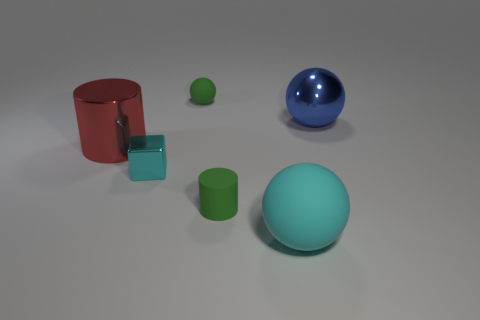Can you describe the shapes and their arrangements in the image? Certainly! The image features a collection of geometric shapes neatly spaced on a flat surface. At the forefront, there's a large teal-colored matte sphere. Slightly behind and to the left is a smaller aqua-colored cube, resting on its edge beside a vertically standing red matte cylinder. Additionally, there's a petite lime-green sphere nearby, creating a contrast in size and color. Lastly, a blue glossy sphere takes a prominent position slightly separated from the other objects, completing the set of items clustered together. 